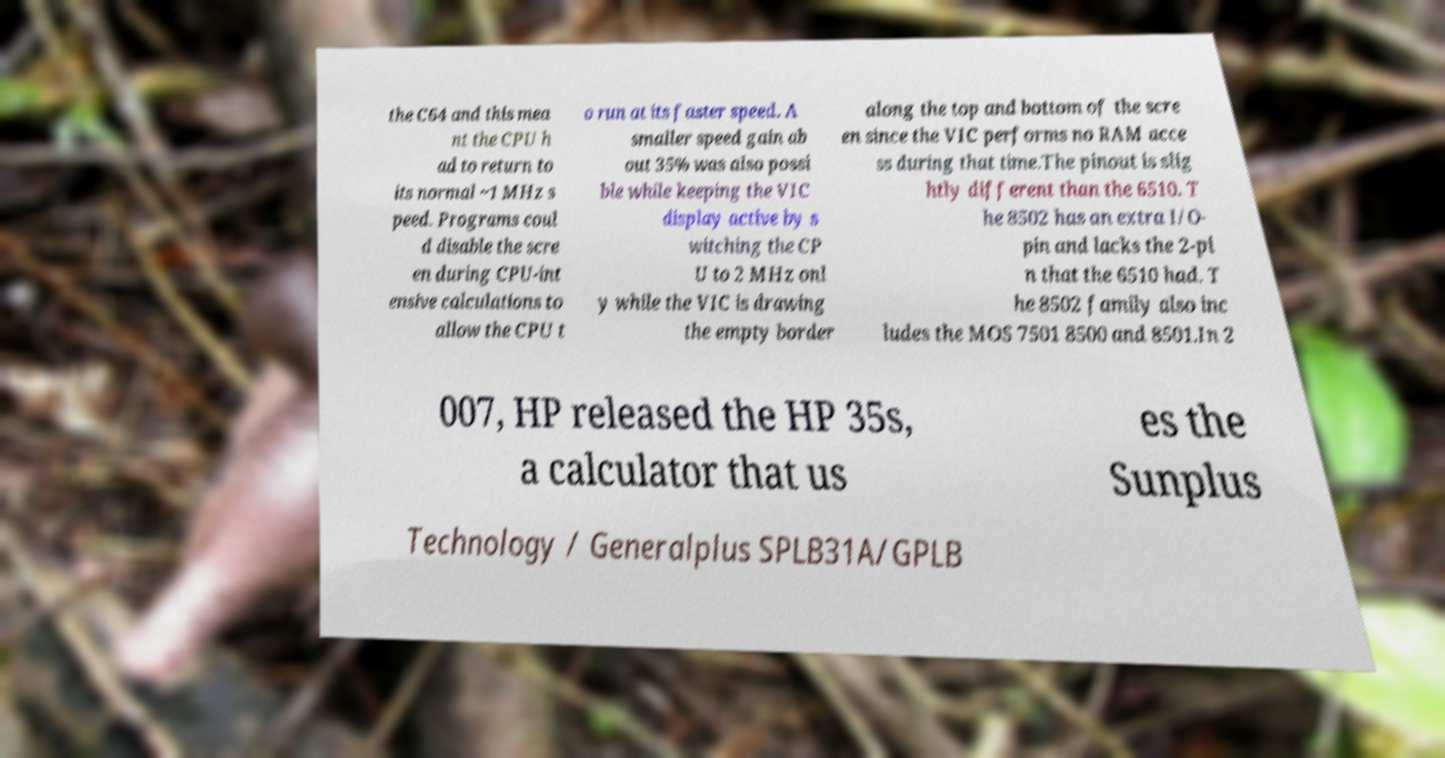Please read and relay the text visible in this image. What does it say? the C64 and this mea nt the CPU h ad to return to its normal ~1 MHz s peed. Programs coul d disable the scre en during CPU-int ensive calculations to allow the CPU t o run at its faster speed. A smaller speed gain ab out 35% was also possi ble while keeping the VIC display active by s witching the CP U to 2 MHz onl y while the VIC is drawing the empty border along the top and bottom of the scre en since the VIC performs no RAM acce ss during that time.The pinout is slig htly different than the 6510. T he 8502 has an extra I/O- pin and lacks the 2-pi n that the 6510 had. T he 8502 family also inc ludes the MOS 7501 8500 and 8501.In 2 007, HP released the HP 35s, a calculator that us es the Sunplus Technology / Generalplus SPLB31A/GPLB 